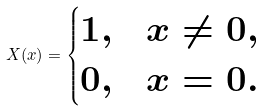<formula> <loc_0><loc_0><loc_500><loc_500>X ( x ) = \begin{cases} 1 , & x \neq 0 , \\ 0 , & x = 0 . \end{cases}</formula> 